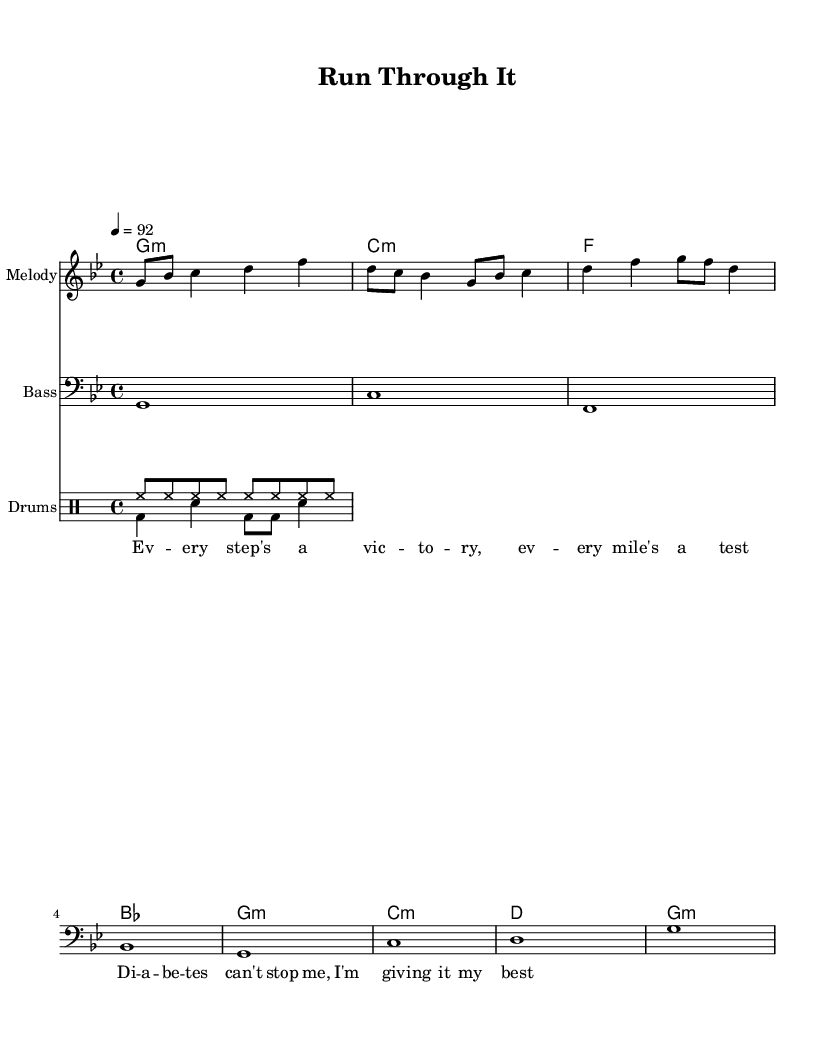What is the key signature of this music? The key signature is G minor, which typically has two flats (B flat and E flat). This can be determined by looking at the beginning of the staff where the key signature is indicated.
Answer: G minor What is the time signature of this music? The time signature is 4/4, which indicates four beats in a measure and a quarter note receives one beat. This is shown at the beginning of the score where the time signature is placed.
Answer: 4/4 What is the tempo marking in BPM? The tempo marking is 92 BPM, which means the piece is to be played at a speed of 92 beats per minute. This is indicated in the score at the tempo marking section right after the time signature.
Answer: 92 How many measures are in the melody section? There are four measures in the melody section, which can be counted by the number of bar lines in the melody part, separating each measure visually.
Answer: 4 Which chord follows the G minor chord in the progression? The next chord after the G minor in the progression is C minor. This can be determined by following the chord sequence provided in the harmonies section beneath the melody.
Answer: C minor What type of percussion instruments are used in this piece? The percussion instruments used are hi-hat and bass drum. This information can be deduced from the drum pattern section, where the symbols for these instruments are clearly indicated.
Answer: Hi-hat and bass drum What is the main lyrical theme of this track? The main lyrical theme is about overcoming challenges related to diabetes through persistence and determination. This can be inferred from the lyrics provided, which highlight victory and best efforts despite health challenges.
Answer: Overcoming challenges 